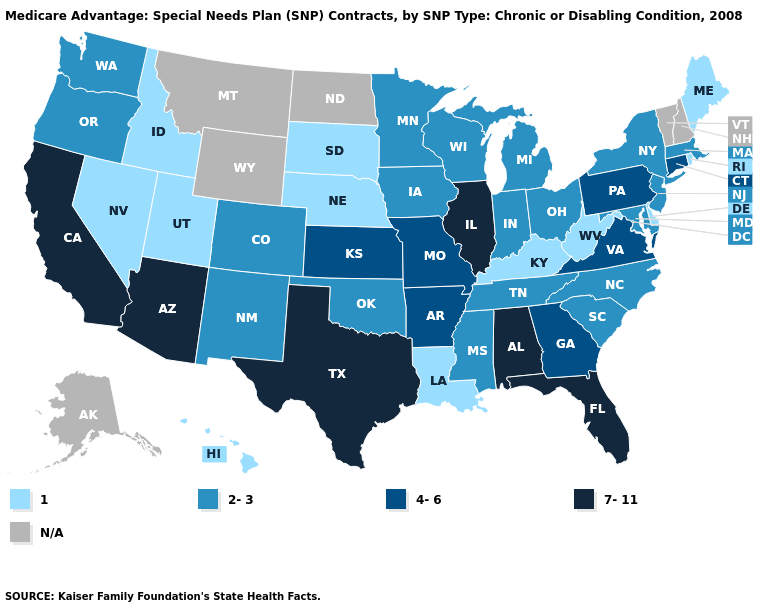What is the value of Massachusetts?
Concise answer only. 2-3. Which states have the lowest value in the MidWest?
Write a very short answer. Nebraska, South Dakota. What is the highest value in the USA?
Write a very short answer. 7-11. Is the legend a continuous bar?
Concise answer only. No. What is the lowest value in the Northeast?
Be succinct. 1. What is the highest value in the USA?
Write a very short answer. 7-11. Among the states that border Maryland , which have the lowest value?
Keep it brief. Delaware, West Virginia. What is the value of Tennessee?
Write a very short answer. 2-3. What is the value of West Virginia?
Write a very short answer. 1. What is the value of South Carolina?
Be succinct. 2-3. Does New York have the highest value in the Northeast?
Write a very short answer. No. Among the states that border Wisconsin , does Michigan have the highest value?
Short answer required. No. What is the lowest value in the USA?
Concise answer only. 1. Is the legend a continuous bar?
Short answer required. No. 